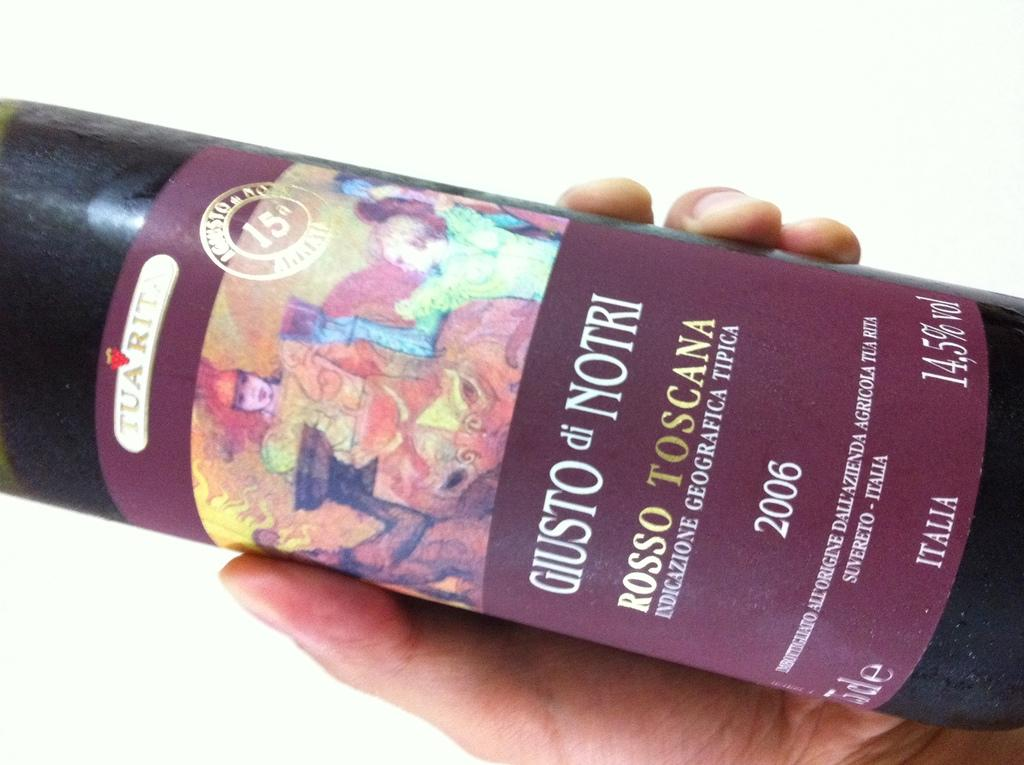<image>
Provide a brief description of the given image. a bottle of Giusto di Notri wine with the word Rosso Toscana written in gold 